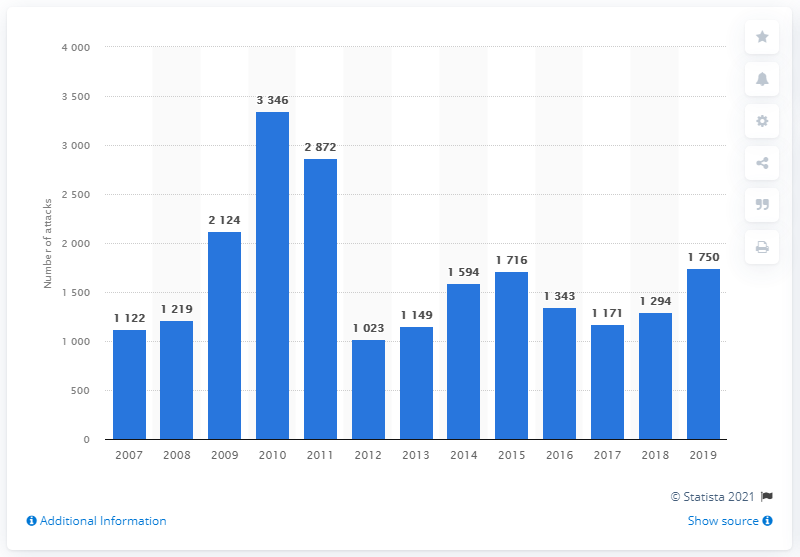Outline some significant characteristics in this image. In the year 2011, the highest number of terrorist attacks occurred in Afghanistan. 